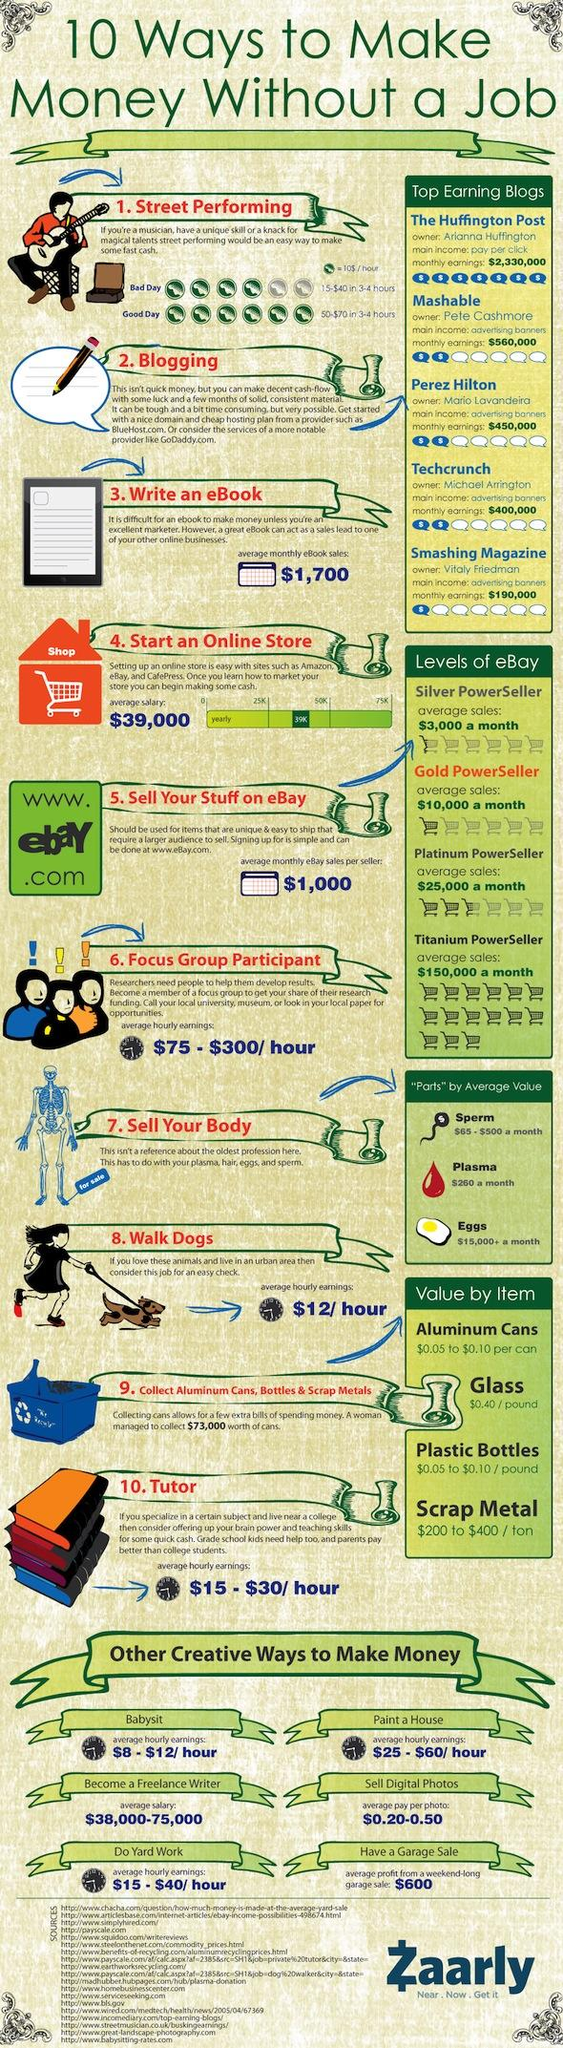Identify some key points in this picture. It is my assertion that the body parts that are likely to fetch the highest amount of money are those that are in high demand, such as eggs. It is reported that Mashable is the blog that receives the highest monthly earnings through advertising banners. 